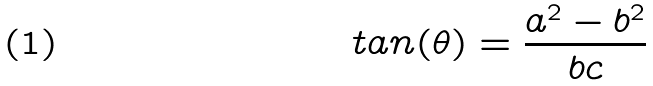Convert formula to latex. <formula><loc_0><loc_0><loc_500><loc_500>t a n ( \theta ) = \frac { a ^ { 2 } - b ^ { 2 } } { b c }</formula> 